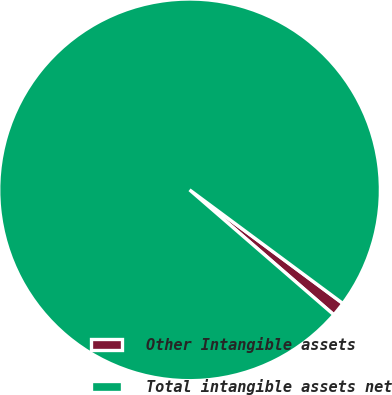<chart> <loc_0><loc_0><loc_500><loc_500><pie_chart><fcel>Other Intangible assets<fcel>Total intangible assets net<nl><fcel>1.21%<fcel>98.79%<nl></chart> 